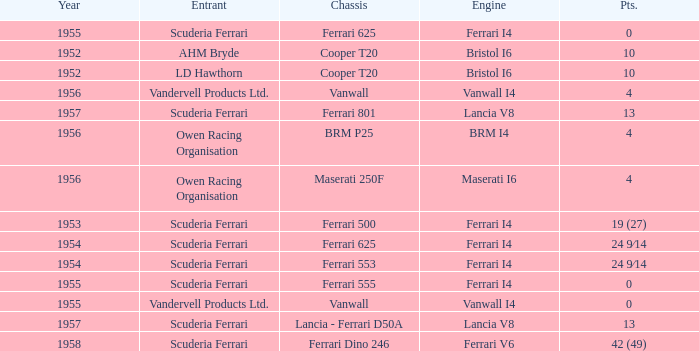How many points were scored when the Chassis is BRM p25? 4.0. I'm looking to parse the entire table for insights. Could you assist me with that? {'header': ['Year', 'Entrant', 'Chassis', 'Engine', 'Pts.'], 'rows': [['1955', 'Scuderia Ferrari', 'Ferrari 625', 'Ferrari I4', '0'], ['1952', 'AHM Bryde', 'Cooper T20', 'Bristol I6', '10'], ['1952', 'LD Hawthorn', 'Cooper T20', 'Bristol I6', '10'], ['1956', 'Vandervell Products Ltd.', 'Vanwall', 'Vanwall I4', '4'], ['1957', 'Scuderia Ferrari', 'Ferrari 801', 'Lancia V8', '13'], ['1956', 'Owen Racing Organisation', 'BRM P25', 'BRM I4', '4'], ['1956', 'Owen Racing Organisation', 'Maserati 250F', 'Maserati I6', '4'], ['1953', 'Scuderia Ferrari', 'Ferrari 500', 'Ferrari I4', '19 (27)'], ['1954', 'Scuderia Ferrari', 'Ferrari 625', 'Ferrari I4', '24 9⁄14'], ['1954', 'Scuderia Ferrari', 'Ferrari 553', 'Ferrari I4', '24 9⁄14'], ['1955', 'Scuderia Ferrari', 'Ferrari 555', 'Ferrari I4', '0'], ['1955', 'Vandervell Products Ltd.', 'Vanwall', 'Vanwall I4', '0'], ['1957', 'Scuderia Ferrari', 'Lancia - Ferrari D50A', 'Lancia V8', '13'], ['1958', 'Scuderia Ferrari', 'Ferrari Dino 246', 'Ferrari V6', '42 (49)']]} 